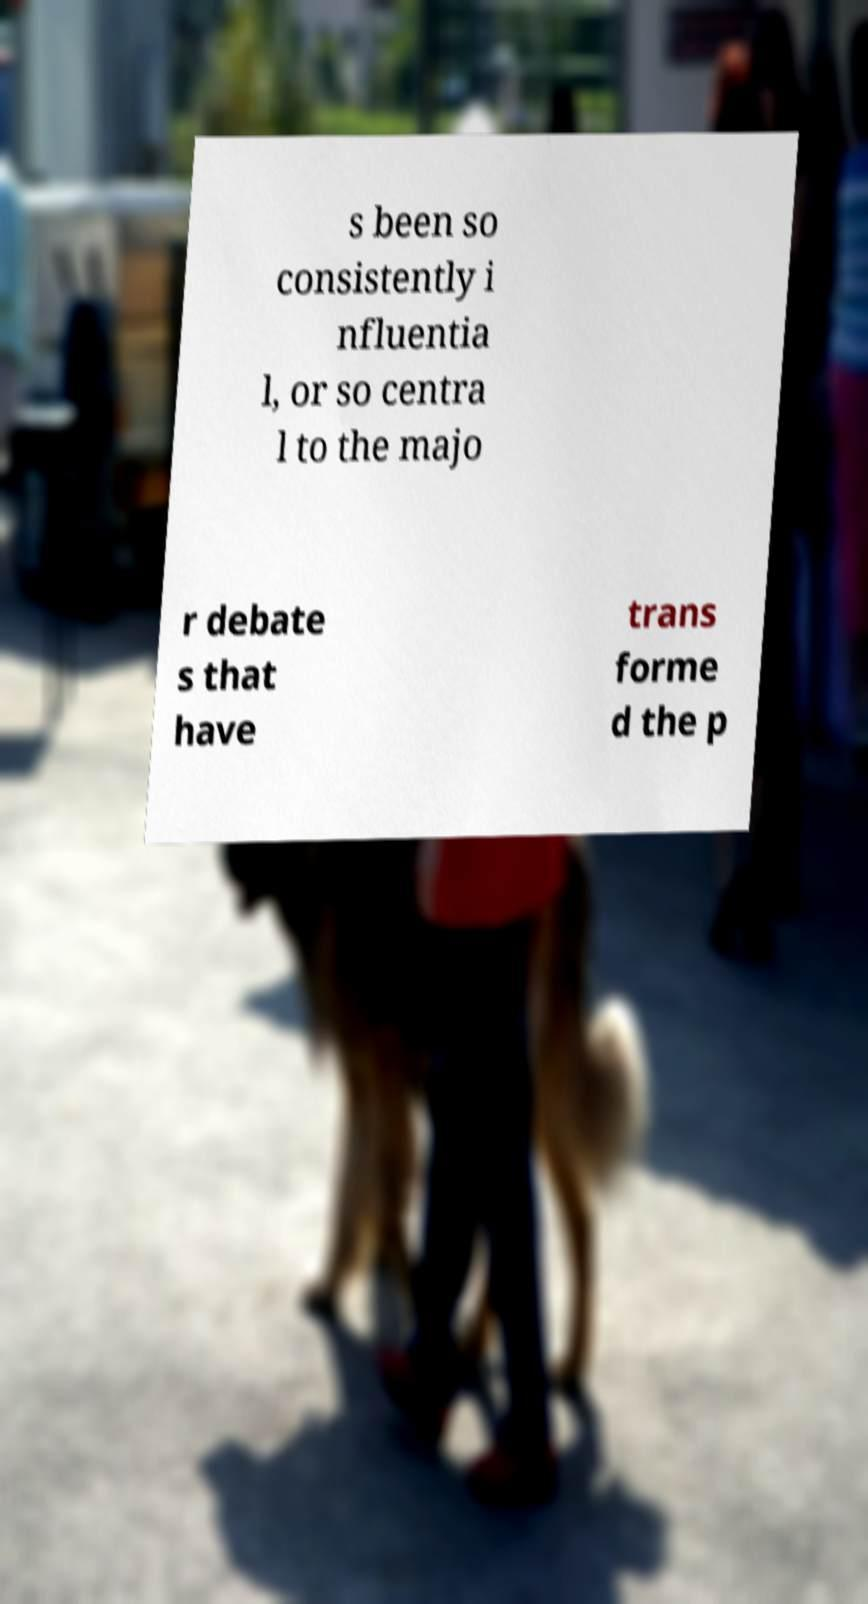Could you extract and type out the text from this image? s been so consistently i nfluentia l, or so centra l to the majo r debate s that have trans forme d the p 